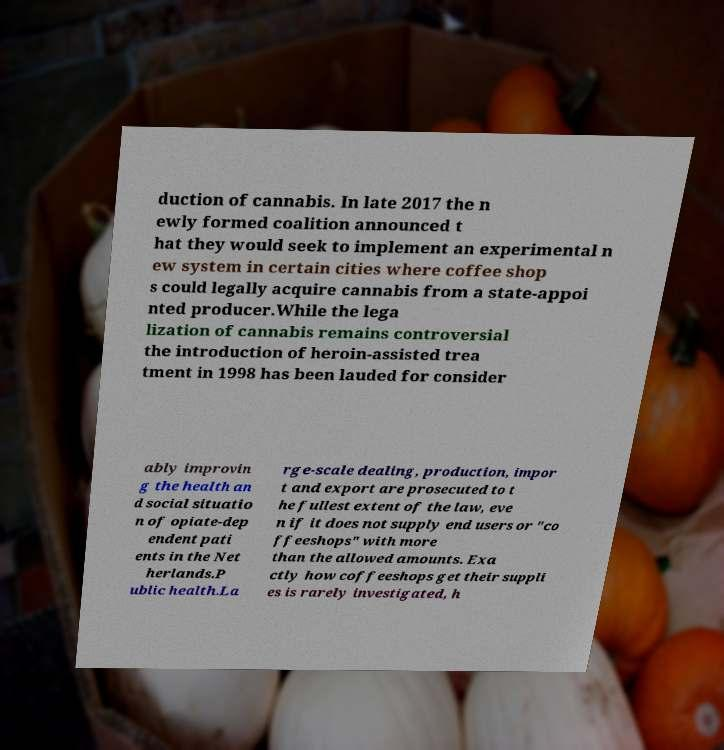Please identify and transcribe the text found in this image. duction of cannabis. In late 2017 the n ewly formed coalition announced t hat they would seek to implement an experimental n ew system in certain cities where coffee shop s could legally acquire cannabis from a state-appoi nted producer.While the lega lization of cannabis remains controversial the introduction of heroin-assisted trea tment in 1998 has been lauded for consider ably improvin g the health an d social situatio n of opiate-dep endent pati ents in the Net herlands.P ublic health.La rge-scale dealing, production, impor t and export are prosecuted to t he fullest extent of the law, eve n if it does not supply end users or "co ffeeshops" with more than the allowed amounts. Exa ctly how coffeeshops get their suppli es is rarely investigated, h 